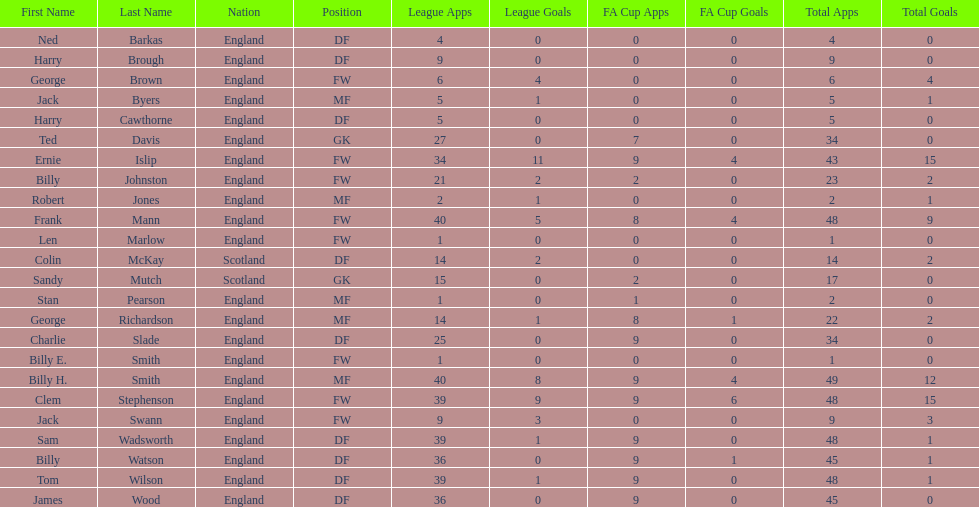Which position is listed the least amount of times on this chart? GK. 